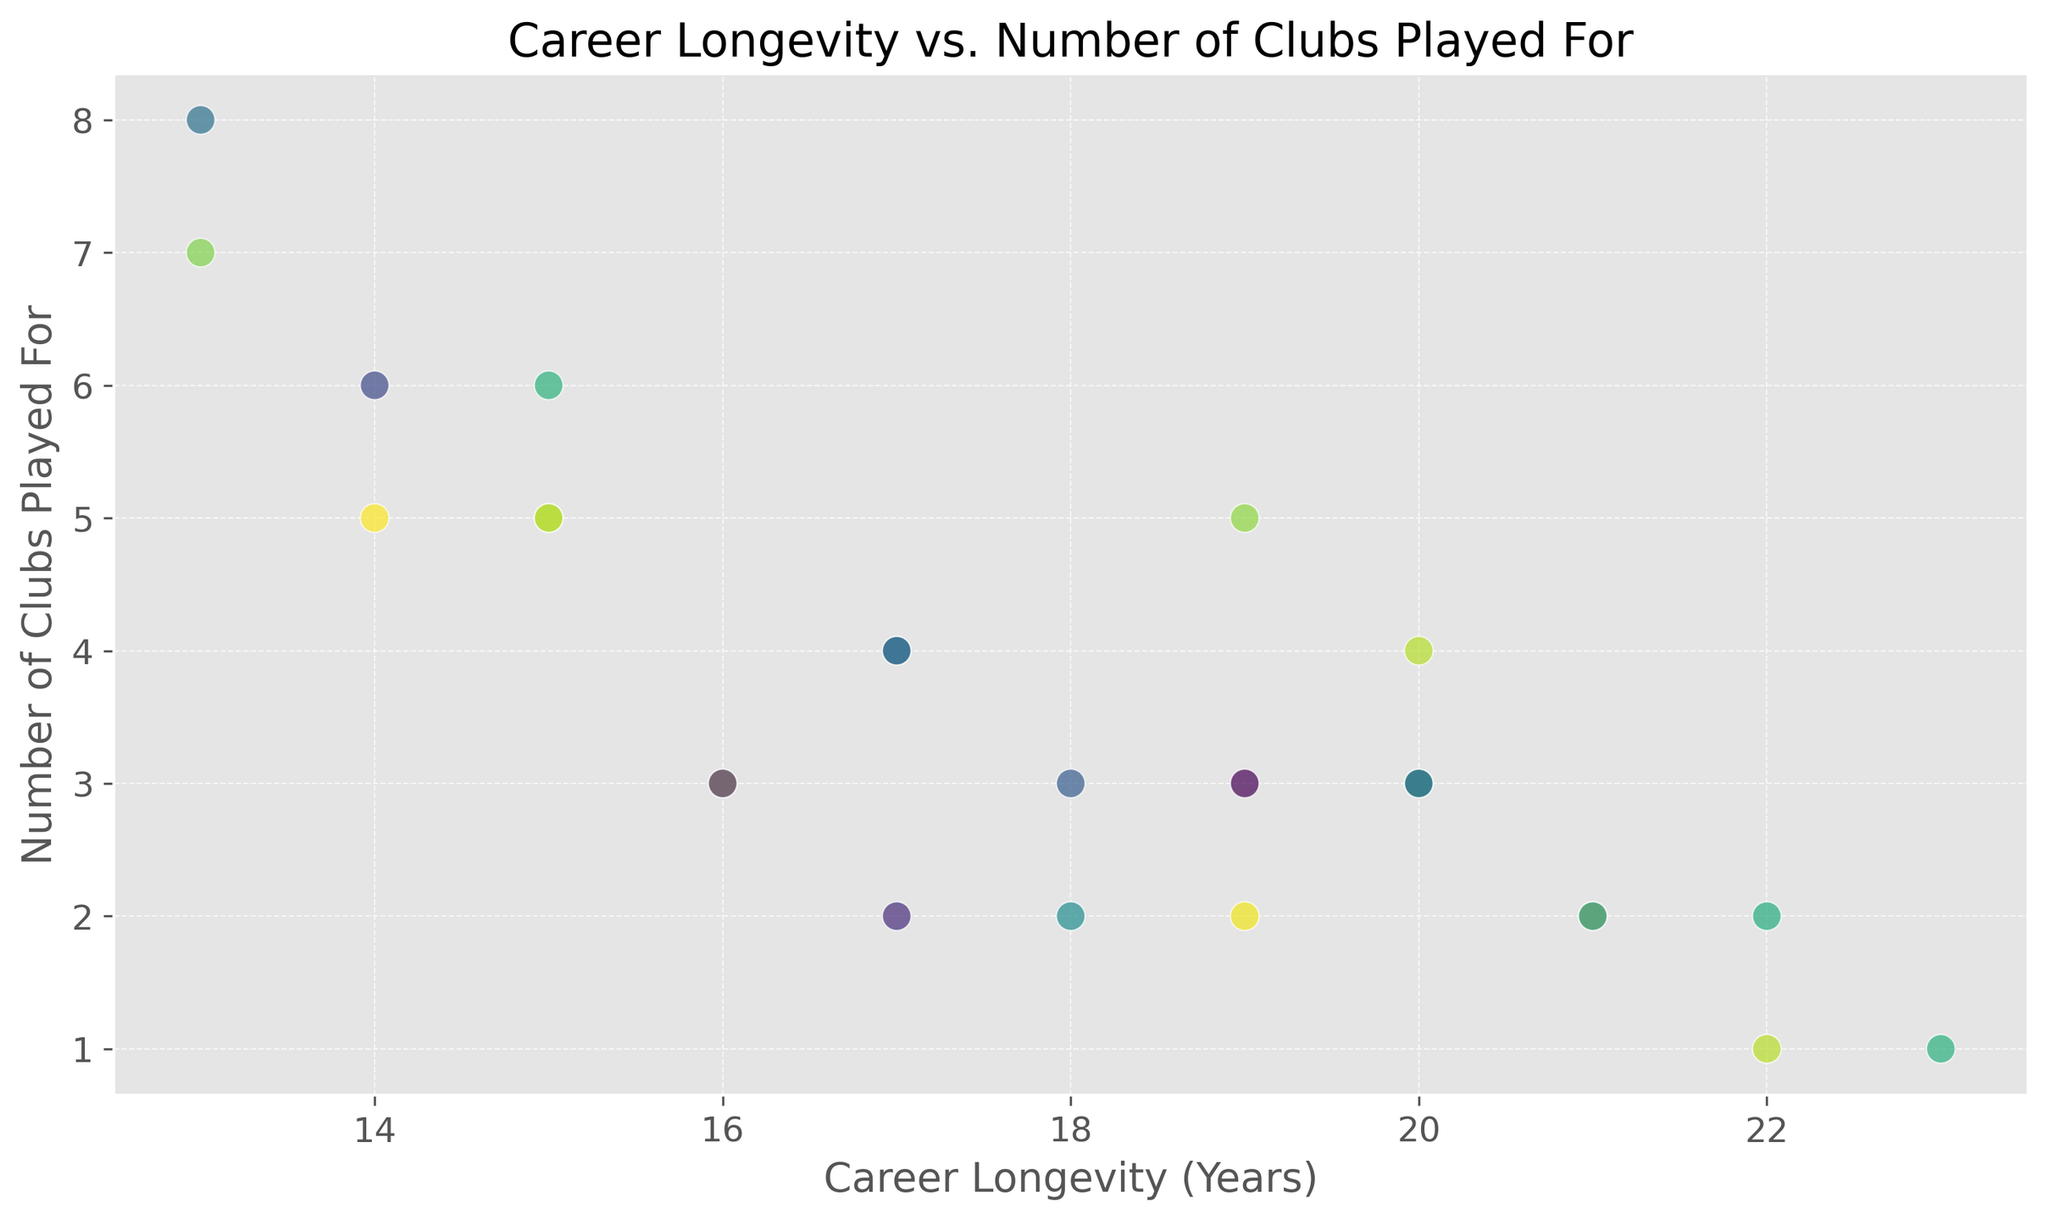What's the range of career longevity in the dataset? The range is calculated by finding the difference between the maximum and minimum career longevities. From the figure, the maximum longevity is 23 years and the minimum is 13 years. Therefore, the range is 23 - 13 = 10 years.
Answer: 10 years How many players played for 1 club? By looking at the scatter plot, we see that there are 2 data points where the career longevity aligns with 1 club played for.
Answer: 2 What is the average number of clubs played for by players with more than 20 years of career longevity? First, identify the players with over 20 years of career longevity: these are at longevities of 21, 22, and 23 years. Their corresponding number of clubs played for are 2, 1, and 1. The average is calculated as (2 + 1 + 1)/3 = 1.33.
Answer: 1.33 Is there a correlation between career longevity and the number of clubs played for? Observing the scatter plot, there seems to be no strong visual correlation. Players with varying career lengths tend to have played for a similar number of clubs.
Answer: No Which player had the shortest career and how many clubs did they play for? The player with the shortest career longevity (13 years) played for 7 clubs, as seen at the data point in the lower part of the scatter plot.
Answer: 7 clubs Do players with longer careers tend to play for fewer clubs? From the visual, players with more than 20 years of longevity played for 1 or 2 clubs, whereas those with shorter careers (less than 15 years) played for a higher number of clubs, suggesting a weak inverse trend.
Answer: Yes What is the maximum number of clubs a player with a career longevity of 20 years played for? There are two points at the 20 years mark which correspond to 3 and 4 clubs played for. Out of these, the maximum is 4.
Answer: 4 clubs How many players have a career longevity of exactly 18 years, and what is the range of clubs they played for? There are two data points at 18 years of career longevity. The number of clubs played for these players are 2 and 3, so the range is 3 - 2 = 1.
Answer: 1 Identify one observation with 4 clubs played for. What is the career longevity of this player? There are multiple observations with exactly 4 clubs. One such player has a career longevity of 17 years.
Answer: 17 years What is the median number of clubs played for players with 15 years of career longevity? There are two players with 15 years of career longevity, having played for 5 and 6 clubs respectively. The median is the average of these two values: (5+6) / 2 = 5.5.
Answer: 5.5 